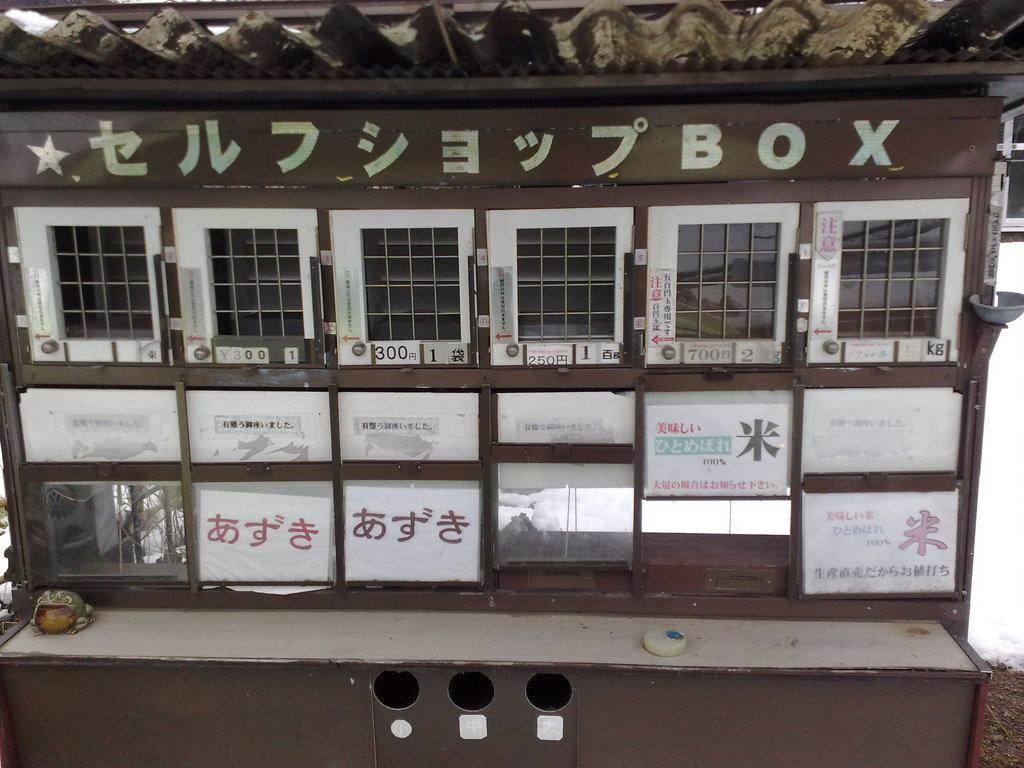<image>
Offer a succinct explanation of the picture presented. A number of mailboxes with Chinese characters and the word Box. 